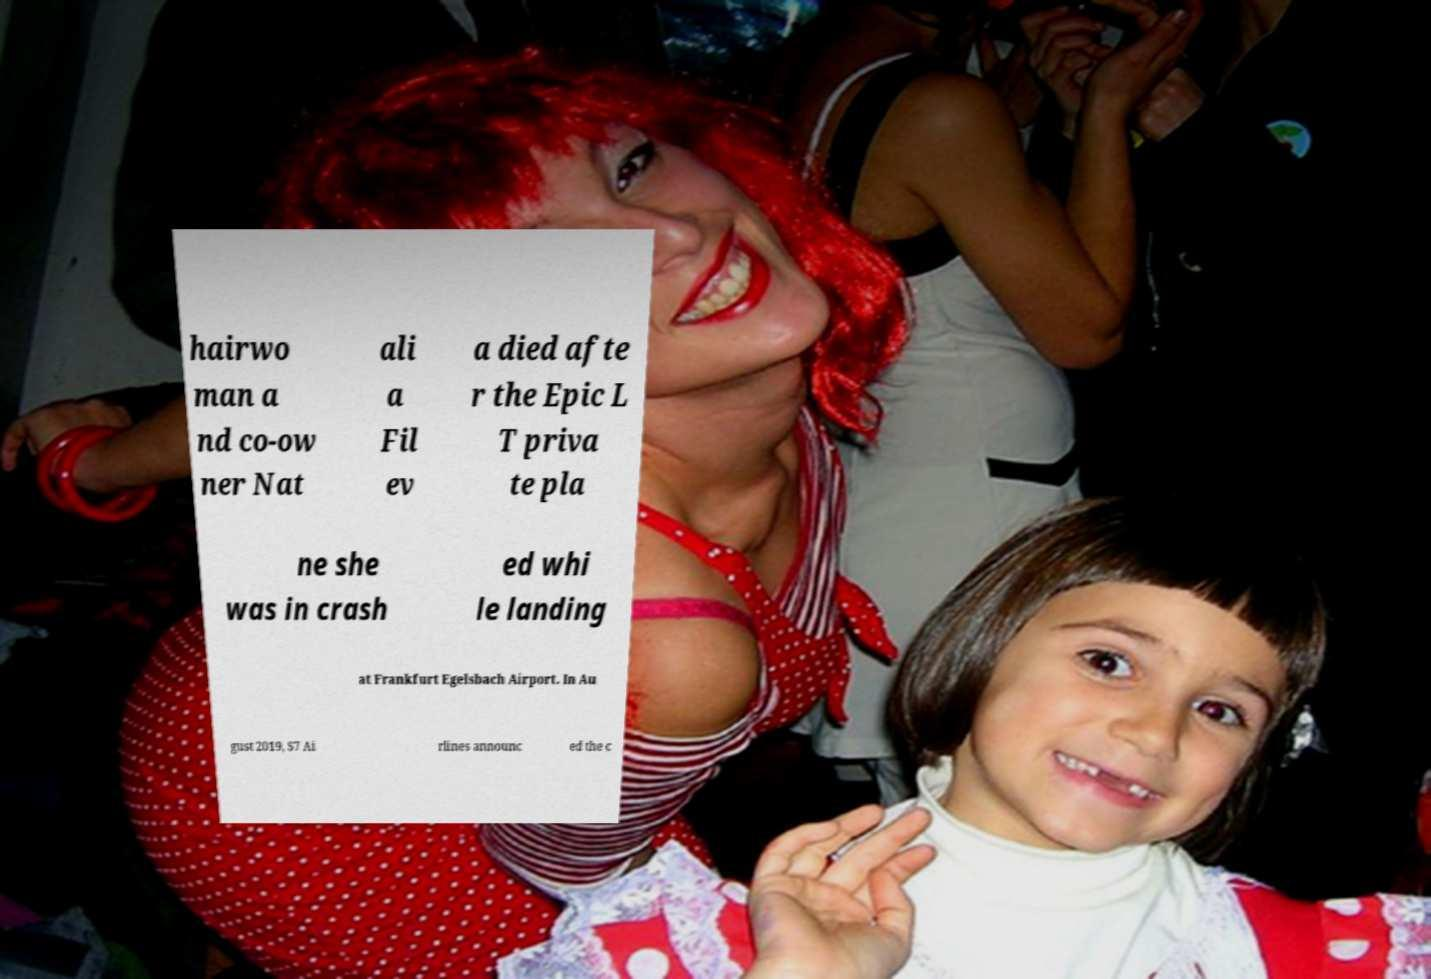What messages or text are displayed in this image? I need them in a readable, typed format. hairwo man a nd co-ow ner Nat ali a Fil ev a died afte r the Epic L T priva te pla ne she was in crash ed whi le landing at Frankfurt Egelsbach Airport. In Au gust 2019, S7 Ai rlines announc ed the c 